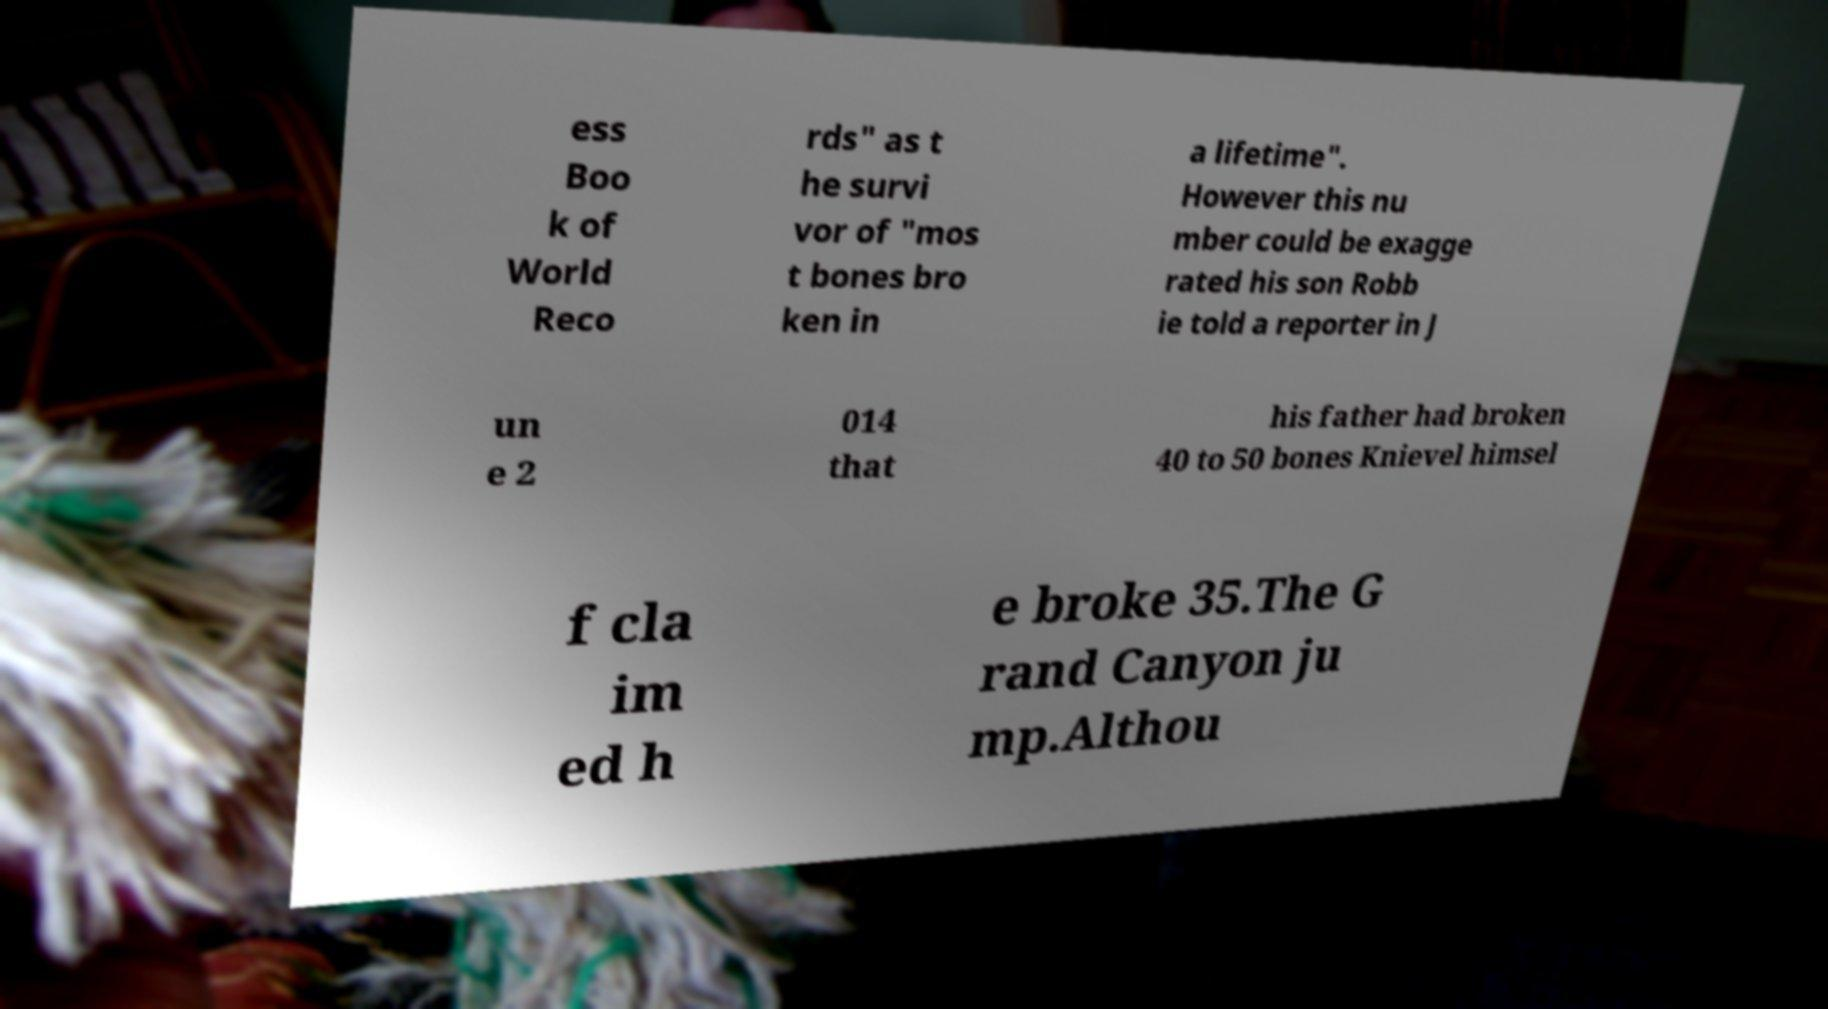Can you accurately transcribe the text from the provided image for me? ess Boo k of World Reco rds" as t he survi vor of "mos t bones bro ken in a lifetime". However this nu mber could be exagge rated his son Robb ie told a reporter in J un e 2 014 that his father had broken 40 to 50 bones Knievel himsel f cla im ed h e broke 35.The G rand Canyon ju mp.Althou 